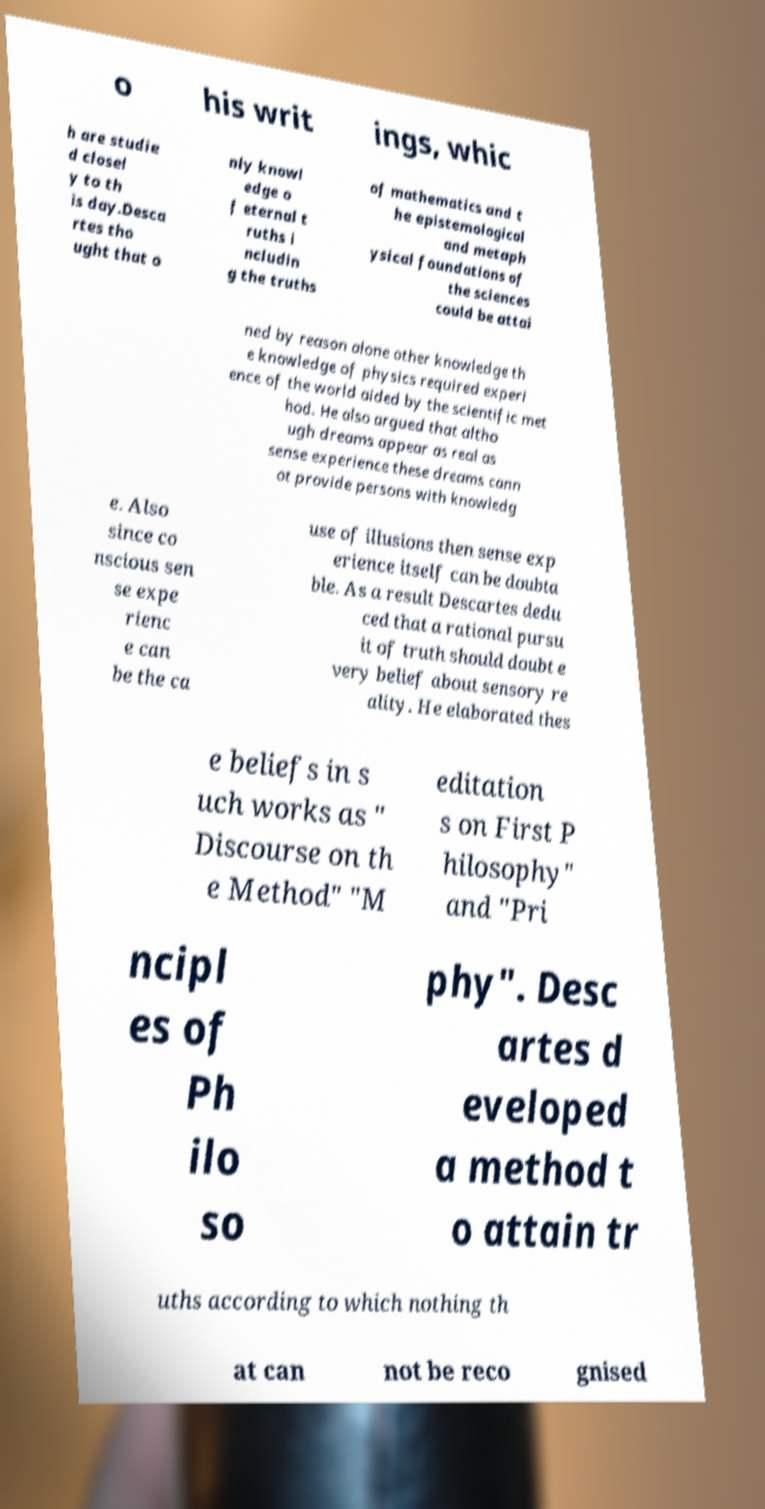There's text embedded in this image that I need extracted. Can you transcribe it verbatim? o his writ ings, whic h are studie d closel y to th is day.Desca rtes tho ught that o nly knowl edge o f eternal t ruths i ncludin g the truths of mathematics and t he epistemological and metaph ysical foundations of the sciences could be attai ned by reason alone other knowledge th e knowledge of physics required experi ence of the world aided by the scientific met hod. He also argued that altho ugh dreams appear as real as sense experience these dreams cann ot provide persons with knowledg e. Also since co nscious sen se expe rienc e can be the ca use of illusions then sense exp erience itself can be doubta ble. As a result Descartes dedu ced that a rational pursu it of truth should doubt e very belief about sensory re ality. He elaborated thes e beliefs in s uch works as " Discourse on th e Method" "M editation s on First P hilosophy" and "Pri ncipl es of Ph ilo so phy". Desc artes d eveloped a method t o attain tr uths according to which nothing th at can not be reco gnised 